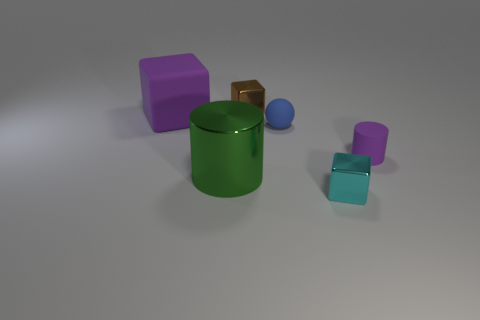Add 2 tiny metallic blocks. How many objects exist? 8 Subtract all spheres. How many objects are left? 5 Add 4 purple matte things. How many purple matte things exist? 6 Subtract 1 green cylinders. How many objects are left? 5 Subtract all cyan metal spheres. Subtract all big blocks. How many objects are left? 5 Add 2 small blue matte spheres. How many small blue matte spheres are left? 3 